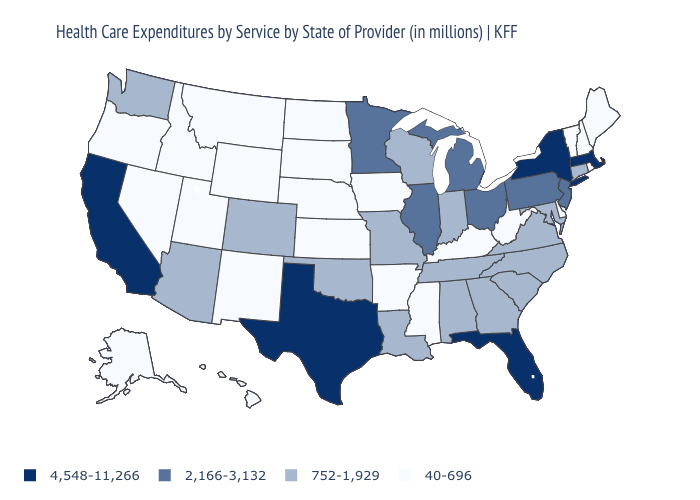What is the value of Mississippi?
Quick response, please. 40-696. What is the value of Utah?
Answer briefly. 40-696. What is the value of Massachusetts?
Quick response, please. 4,548-11,266. Which states have the lowest value in the USA?
Be succinct. Alaska, Arkansas, Delaware, Hawaii, Idaho, Iowa, Kansas, Kentucky, Maine, Mississippi, Montana, Nebraska, Nevada, New Hampshire, New Mexico, North Dakota, Oregon, Rhode Island, South Dakota, Utah, Vermont, West Virginia, Wyoming. Name the states that have a value in the range 2,166-3,132?
Short answer required. Illinois, Michigan, Minnesota, New Jersey, Ohio, Pennsylvania. What is the value of West Virginia?
Keep it brief. 40-696. What is the value of Massachusetts?
Be succinct. 4,548-11,266. Name the states that have a value in the range 40-696?
Give a very brief answer. Alaska, Arkansas, Delaware, Hawaii, Idaho, Iowa, Kansas, Kentucky, Maine, Mississippi, Montana, Nebraska, Nevada, New Hampshire, New Mexico, North Dakota, Oregon, Rhode Island, South Dakota, Utah, Vermont, West Virginia, Wyoming. What is the highest value in the USA?
Be succinct. 4,548-11,266. Name the states that have a value in the range 752-1,929?
Keep it brief. Alabama, Arizona, Colorado, Connecticut, Georgia, Indiana, Louisiana, Maryland, Missouri, North Carolina, Oklahoma, South Carolina, Tennessee, Virginia, Washington, Wisconsin. Is the legend a continuous bar?
Quick response, please. No. What is the value of Texas?
Give a very brief answer. 4,548-11,266. Name the states that have a value in the range 752-1,929?
Answer briefly. Alabama, Arizona, Colorado, Connecticut, Georgia, Indiana, Louisiana, Maryland, Missouri, North Carolina, Oklahoma, South Carolina, Tennessee, Virginia, Washington, Wisconsin. 